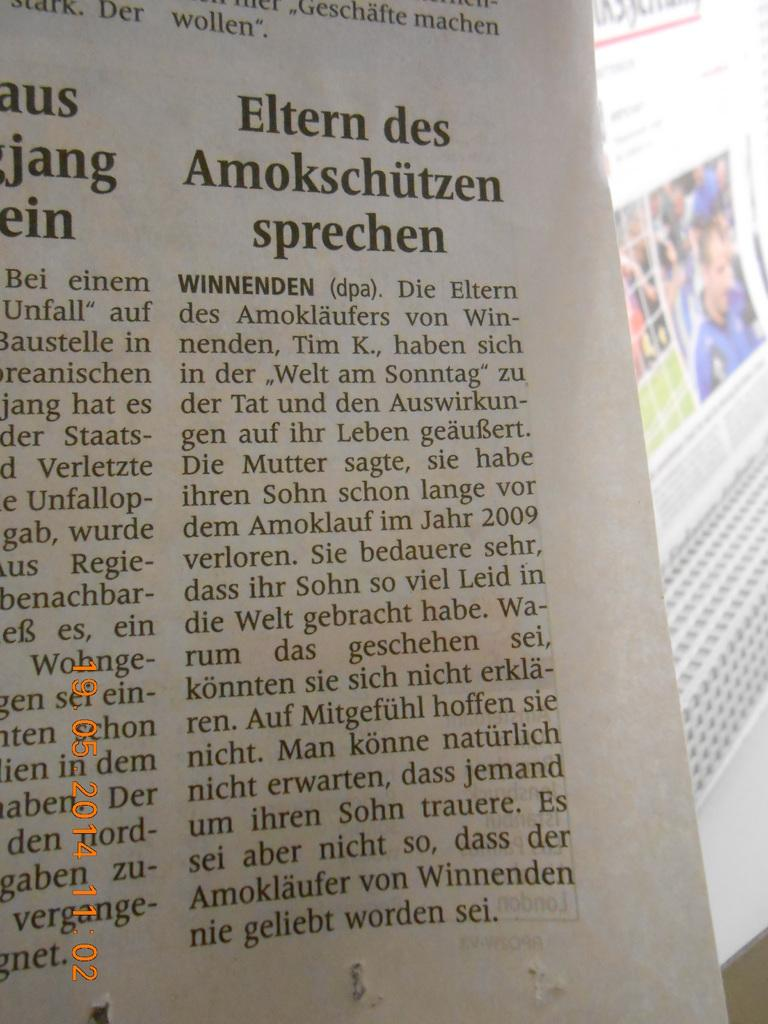<image>
Provide a brief description of the given image. An article is titled Eltern des Amokschutzen sprechen. 